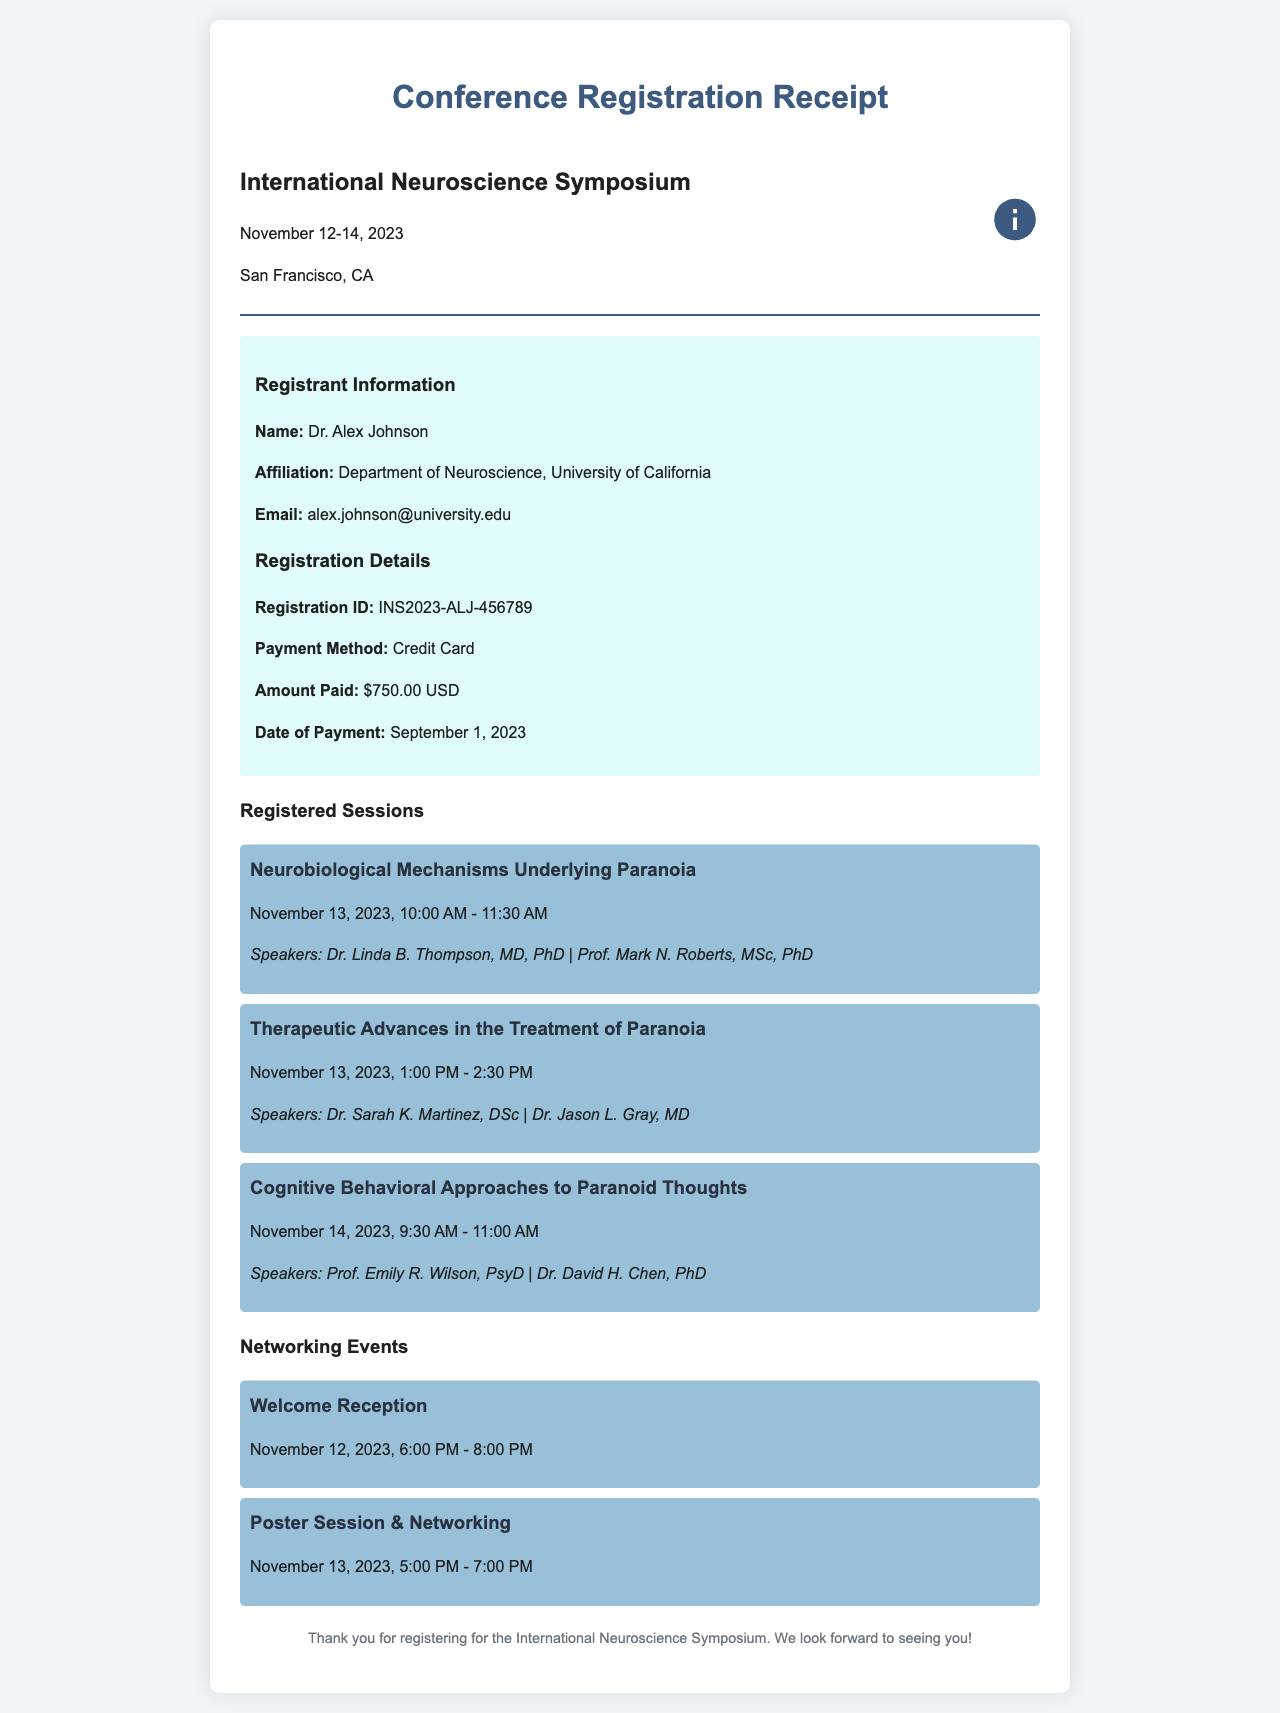What is the registration ID? The registration ID is mentioned in the receipt details section, identified as INS2023-ALJ-456789.
Answer: INS2023-ALJ-456789 What is the total amount paid for registration? The amount paid is specified clearly in the registration details as $750.00 USD.
Answer: $750.00 USD On what date does the conference start? The start date is indicated at the top of the document under the conference title, shown as November 12, 2023.
Answer: November 12, 2023 What is the time for the session on "Cognitive Behavioral Approaches to Paranoid Thoughts"? The time for that session is detailed in the sessions section as November 14, 2023, 9:30 AM - 11:00 AM.
Answer: November 14, 2023, 9:30 AM - 11:00 AM Which session focuses on therapeutic advances? The session titled "Therapeutic Advances in the Treatment of Paranoia" directly addresses therapeutic advances.
Answer: Therapeutic Advances in the Treatment of Paranoia 